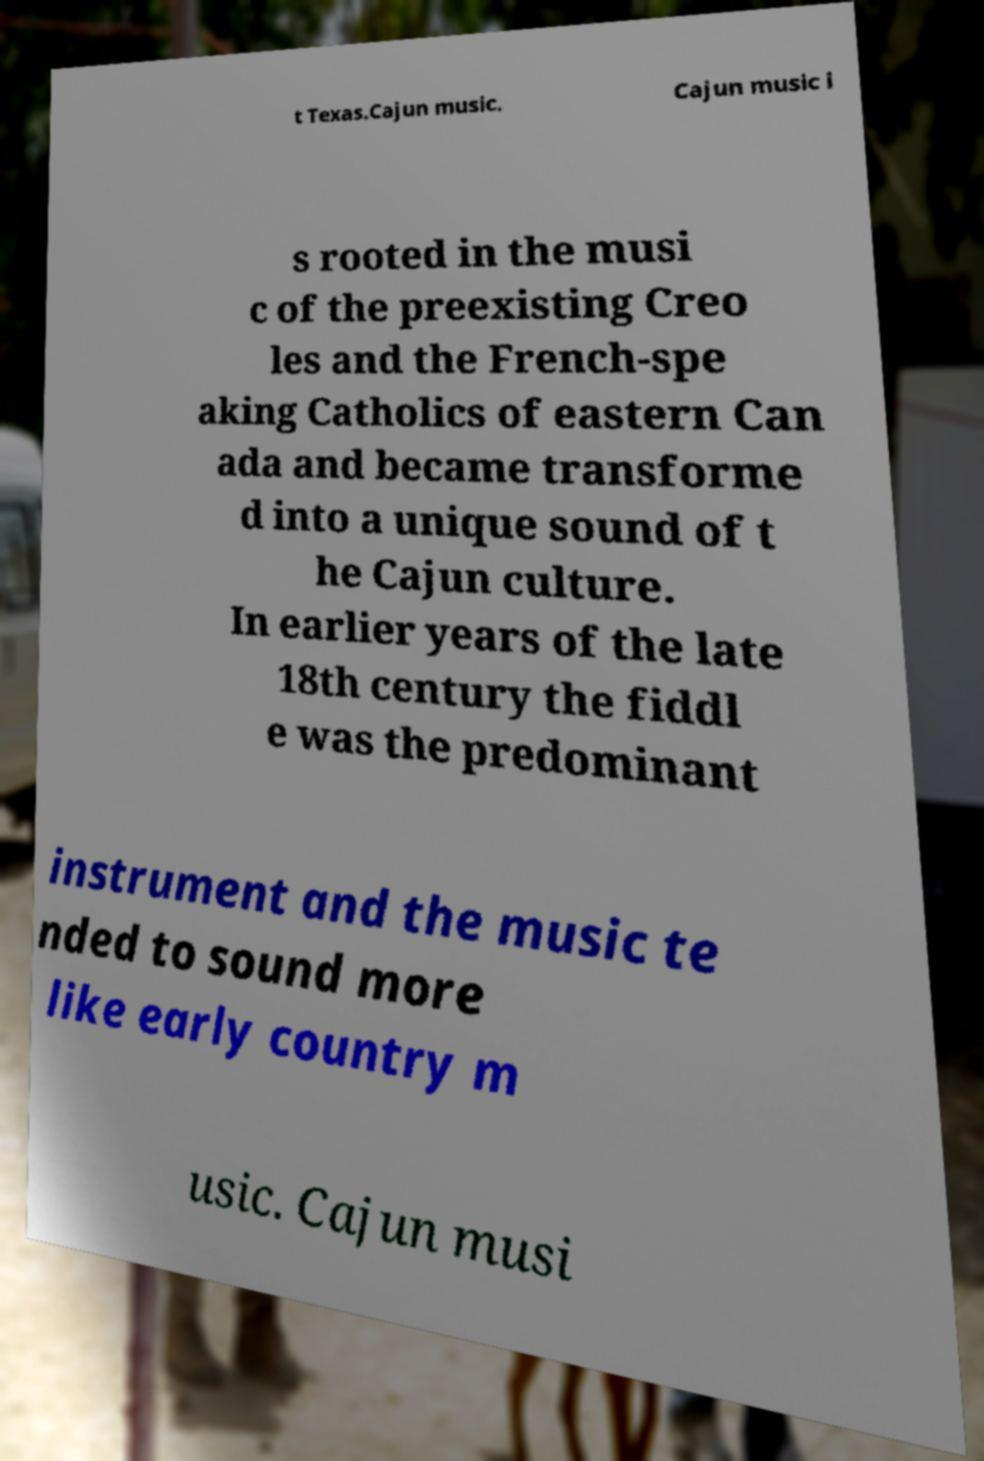Could you extract and type out the text from this image? t Texas.Cajun music. Cajun music i s rooted in the musi c of the preexisting Creo les and the French-spe aking Catholics of eastern Can ada and became transforme d into a unique sound of t he Cajun culture. In earlier years of the late 18th century the fiddl e was the predominant instrument and the music te nded to sound more like early country m usic. Cajun musi 